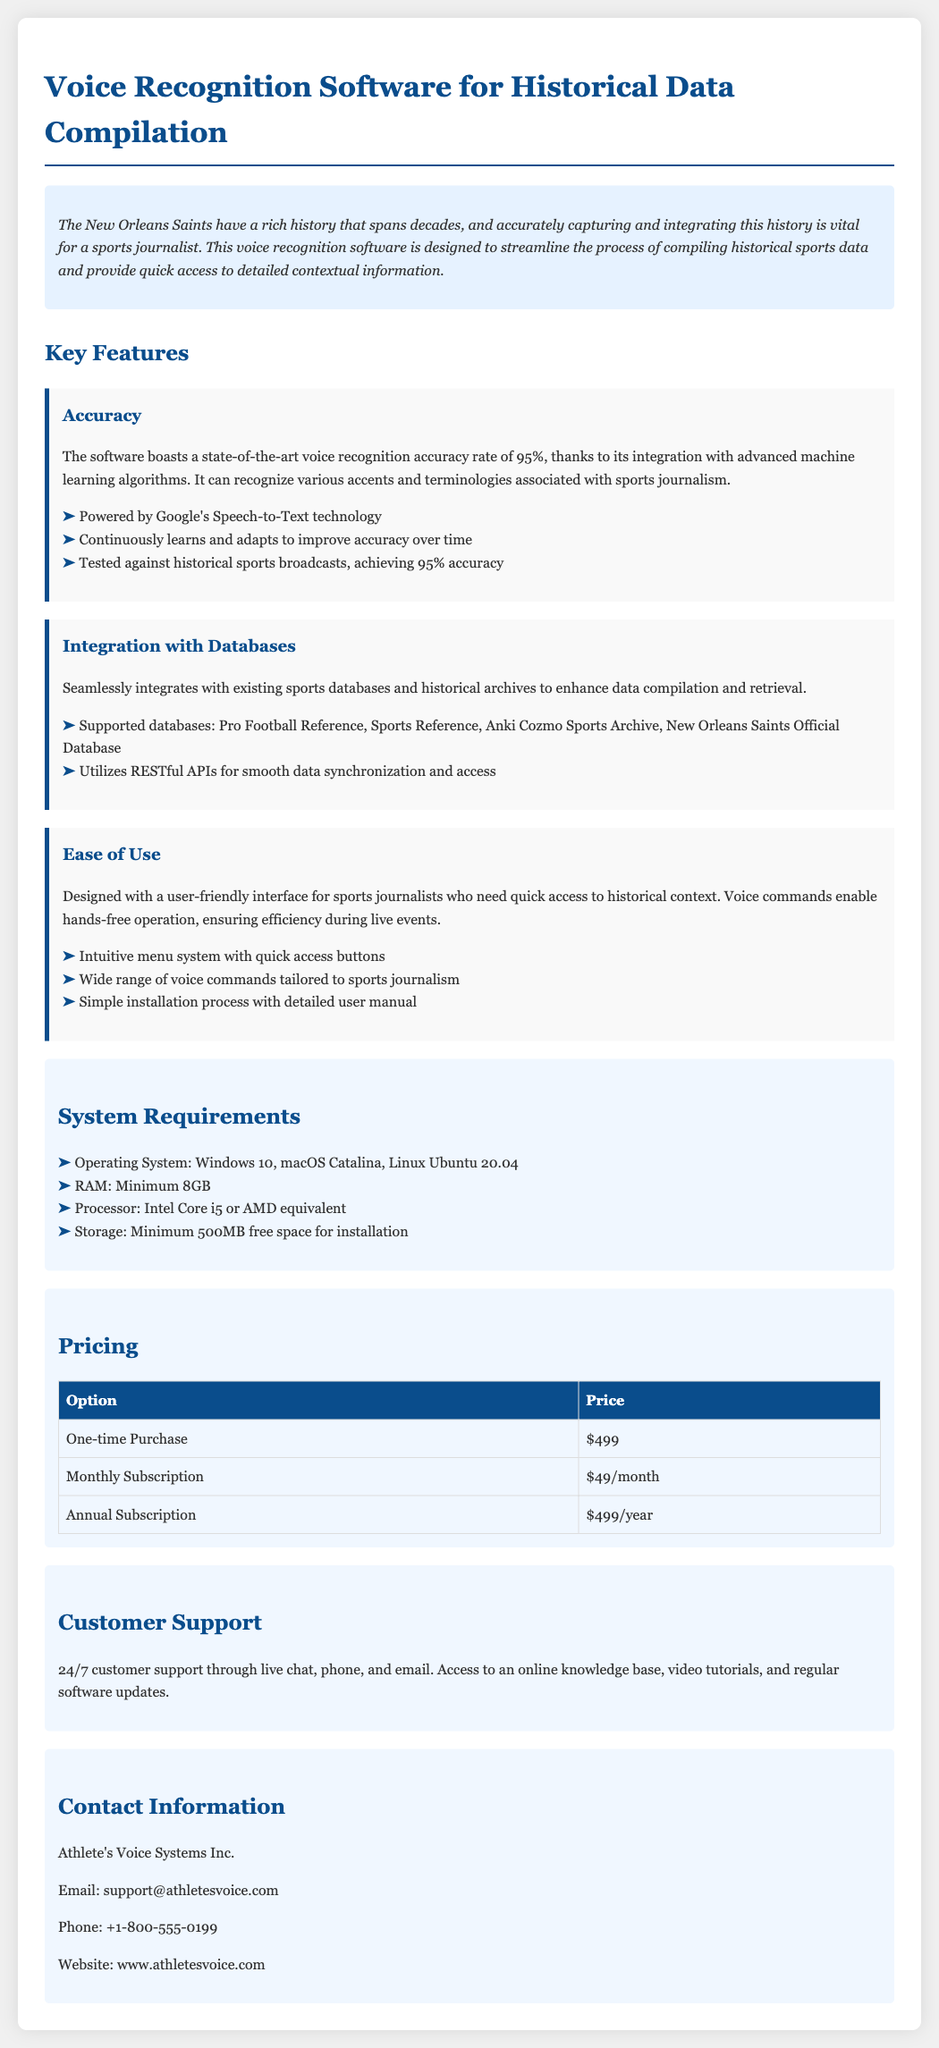What is the accuracy rate of the software? The document states that the software boasts a voice recognition accuracy rate of 95%.
Answer: 95% Which databases does the software integrate with? The software integrates with Pro Football Reference, Sports Reference, Anki Cozmo Sports Archive, and New Orleans Saints Official Database.
Answer: Pro Football Reference, Sports Reference, Anki Cozmo Sports Archive, New Orleans Saints Official Database What is the minimum RAM requirement? According to the system requirements section, the minimum RAM requirement is 8GB.
Answer: 8GB What technology powers the voice recognition? The document mentions that the software is powered by Google's Speech-to-Text technology.
Answer: Google's Speech-to-Text technology How does the software improve over time? The document states that it continuously learns and adapts to improve accuracy over time.
Answer: Continuously learns and adapts What types of subscriptions are offered? The pricing section includes One-time Purchase, Monthly Subscription, and Annual Subscription options.
Answer: One-time Purchase, Monthly Subscription, Annual Subscription What customer support options are available? The document lists 24/7 customer support through live chat, phone, and email as available options.
Answer: Live chat, phone, and email What is the contact email for support? The document provides the email address support@athletesvoice.com as the contact information for support.
Answer: support@athletesvoice.com 